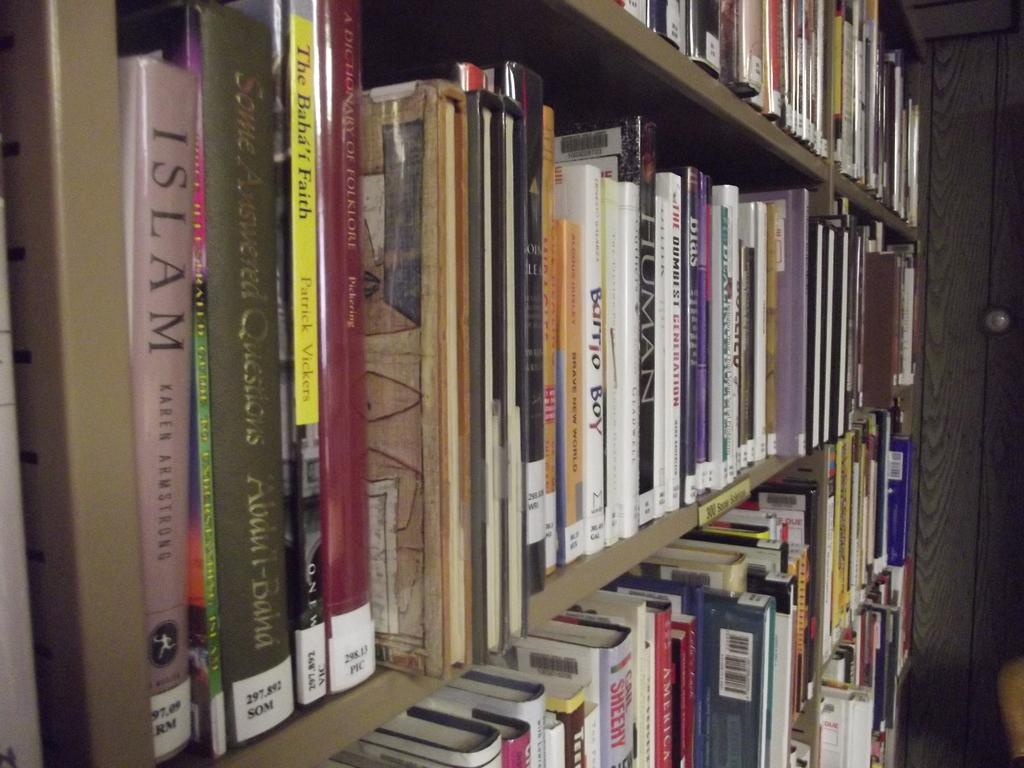<image>
Render a clear and concise summary of the photo. the word Islam is on the purple book 